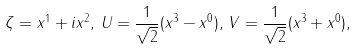<formula> <loc_0><loc_0><loc_500><loc_500>\zeta = x ^ { 1 } + i x ^ { 2 } , \, { U } = \frac { 1 } { \sqrt { 2 } } ( x ^ { 3 } - x ^ { 0 } ) , \, { V } = \frac { 1 } { \sqrt { 2 } } ( x ^ { 3 } + x ^ { 0 } ) ,</formula> 